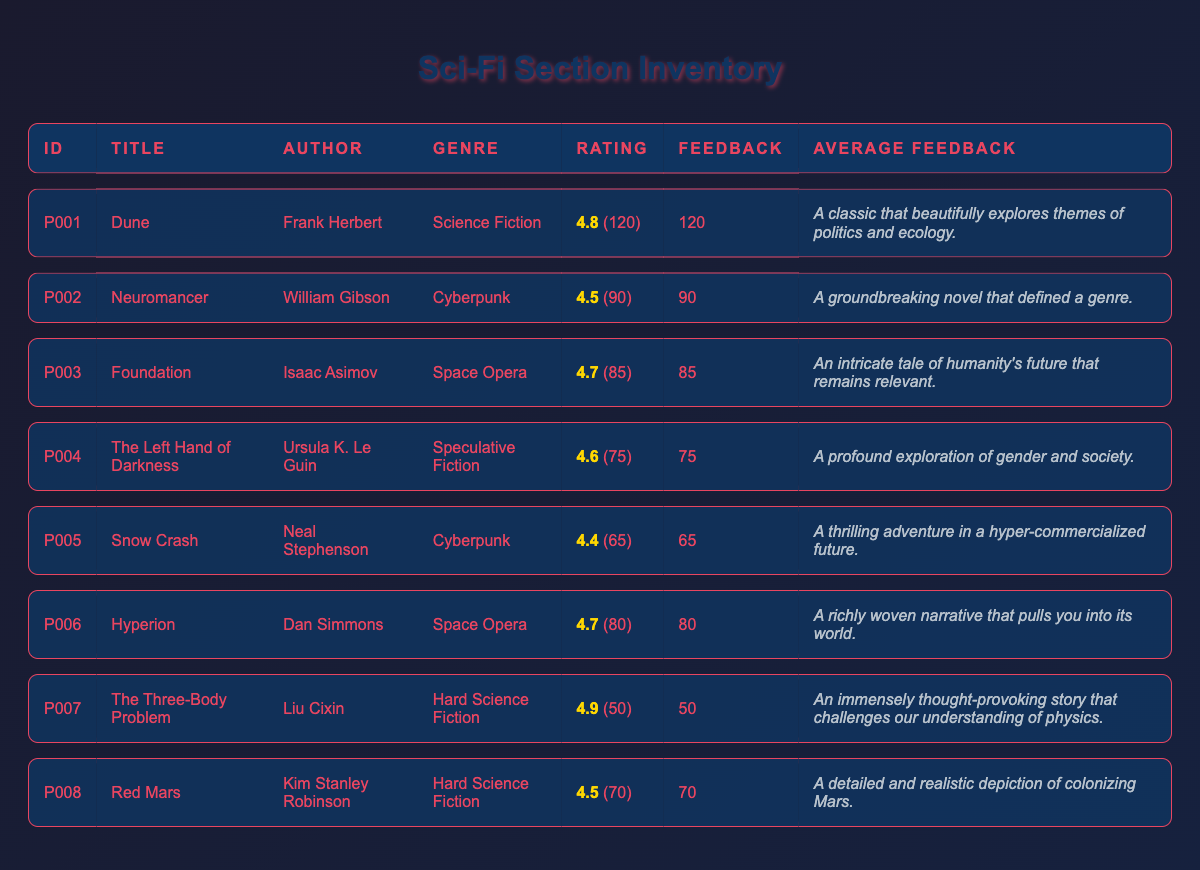What is the customer rating of "Dune"? The table shows that the customer rating for "Dune" is listed directly under the Rating column as 4.8.
Answer: 4.8 How many feedback counts does "The Left Hand of Darkness" have? According to the table, the feedback count for "The Left Hand of Darkness" is displayed as 75.
Answer: 75 Which book has the highest customer rating? By examining the ratings provided, "The Three-Body Problem" has the highest customer rating of 4.9, more than any other book in the list.
Answer: The Three-Body Problem What is the average customer rating for the Space Opera genre? The two books classified under Space Opera are "Foundation" with a rating of 4.7 and "Hyperion" with a rating of 4.7. Adding them gives 4.7 + 4.7 = 9.4, and dividing by 2 gives the average rating of 4.7.
Answer: 4.7 Is "Snow Crash" rated lower than 4.5? The customer rating for "Snow Crash" is 4.4, which is less than 4.5.
Answer: Yes How many feedback counts are there in total for all the books? Adding the feedback counts for all books: 120 + 90 + 85 + 75 + 65 + 80 + 50 + 70 = 735.
Answer: 735 Are there more than 100 feedback counts for "Neuromancer"? The feedback count for "Neuromancer" is 90, which is less than 100.
Answer: No Which genres have books rated 4.5 or higher? The ratings for the books are: "Dune" (4.8), "Neuromancer" (4.5), "Foundation" (4.7), "The Left Hand of Darkness" (4.6), "Hyperion" (4.7), "The Three-Body Problem" (4.9), and "Red Mars" (4.5). All of these books have a rating of 4.5 or higher, meaning multiple genres are represented including Science Fiction, Cyberpunk, Space Opera, Speculative Fiction, and Hard Science Fiction.
Answer: Multiple genres What is the difference in feedback counts between "Hyperion" and "Snow Crash"? The feedback count for "Hyperion" is 80 and for "Snow Crash" it is 65. The difference is calculated by subtracting: 80 - 65 = 15.
Answer: 15 